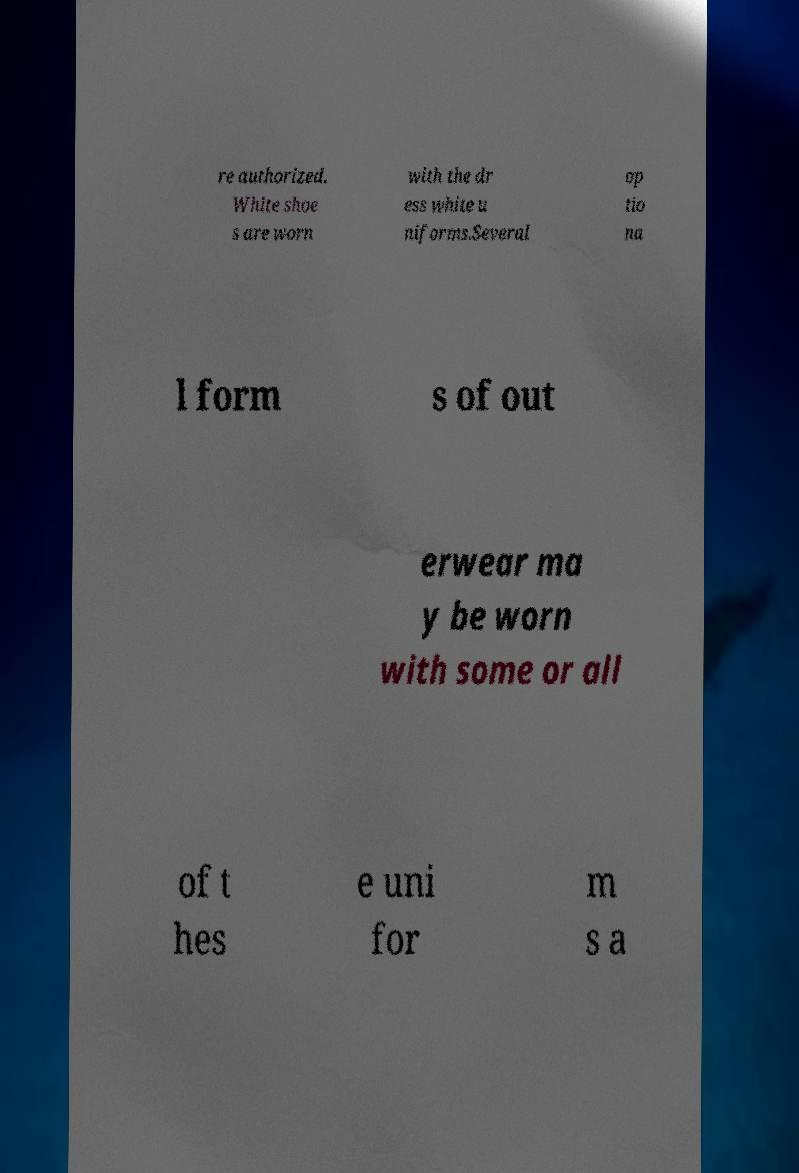Please read and relay the text visible in this image. What does it say? re authorized. White shoe s are worn with the dr ess white u niforms.Several op tio na l form s of out erwear ma y be worn with some or all of t hes e uni for m s a 